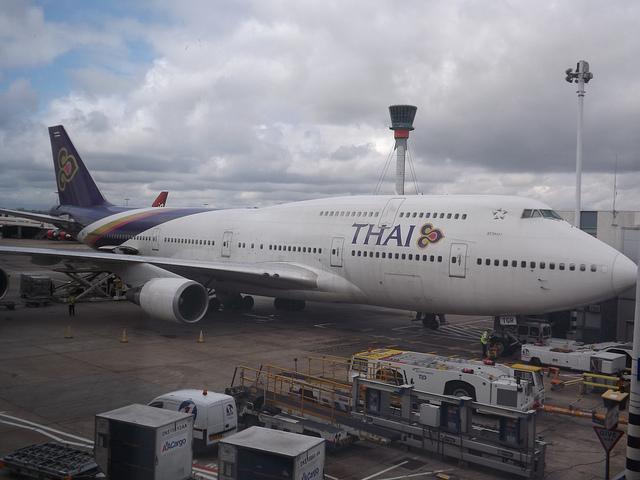Whose plane is this?
Write a very short answer. Thai. How many people in neon vests?
Give a very brief answer. 1. Are there clouds in sky?
Write a very short answer. Yes. What are the metal boxes in the foreground for?
Be succinct. Storage. What country is displayed on the white plane?
Short answer required. Thai. What company name is on the Airplane?
Answer briefly. Thai. What country name is written on the airplane?
Write a very short answer. Thai. What airline is this?
Give a very brief answer. Thai. What airliner is that?
Quick response, please. Thai. 